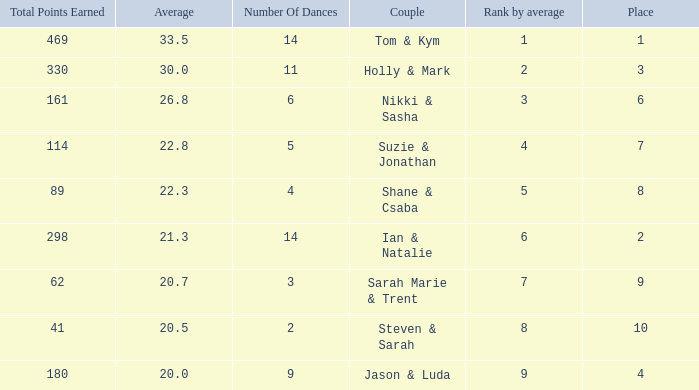What was the name of the couple if the number of dances is 6? Nikki & Sasha. 